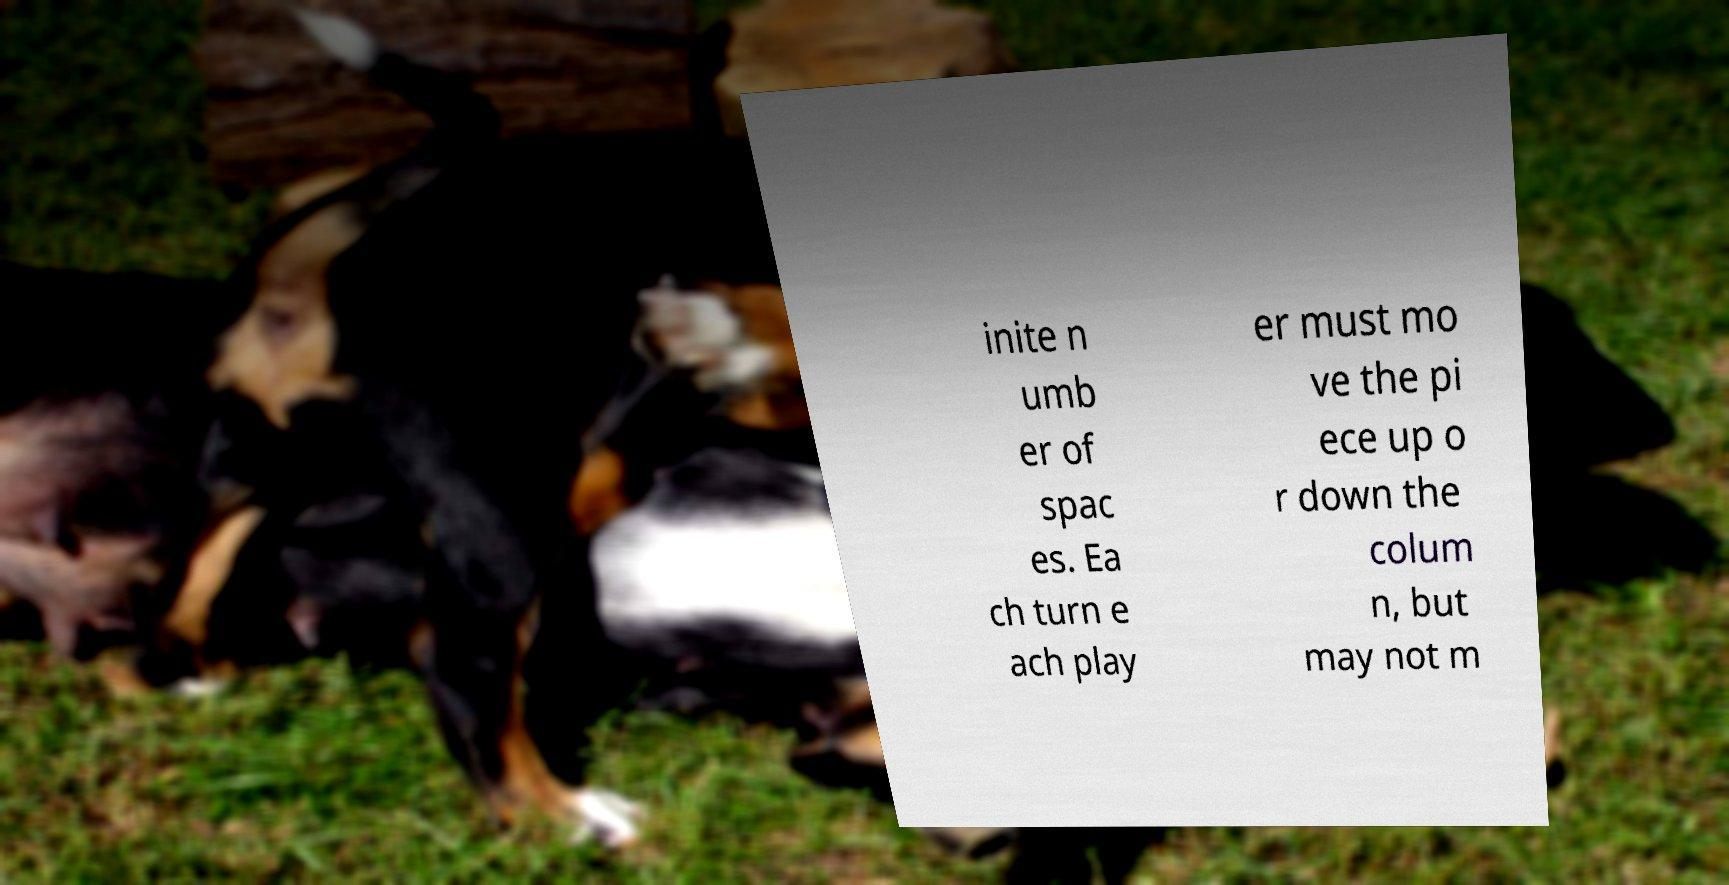There's text embedded in this image that I need extracted. Can you transcribe it verbatim? inite n umb er of spac es. Ea ch turn e ach play er must mo ve the pi ece up o r down the colum n, but may not m 